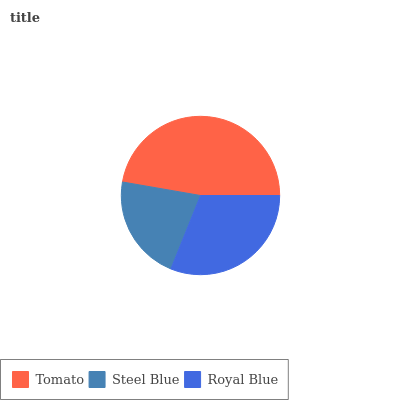Is Steel Blue the minimum?
Answer yes or no. Yes. Is Tomato the maximum?
Answer yes or no. Yes. Is Royal Blue the minimum?
Answer yes or no. No. Is Royal Blue the maximum?
Answer yes or no. No. Is Royal Blue greater than Steel Blue?
Answer yes or no. Yes. Is Steel Blue less than Royal Blue?
Answer yes or no. Yes. Is Steel Blue greater than Royal Blue?
Answer yes or no. No. Is Royal Blue less than Steel Blue?
Answer yes or no. No. Is Royal Blue the high median?
Answer yes or no. Yes. Is Royal Blue the low median?
Answer yes or no. Yes. Is Steel Blue the high median?
Answer yes or no. No. Is Steel Blue the low median?
Answer yes or no. No. 